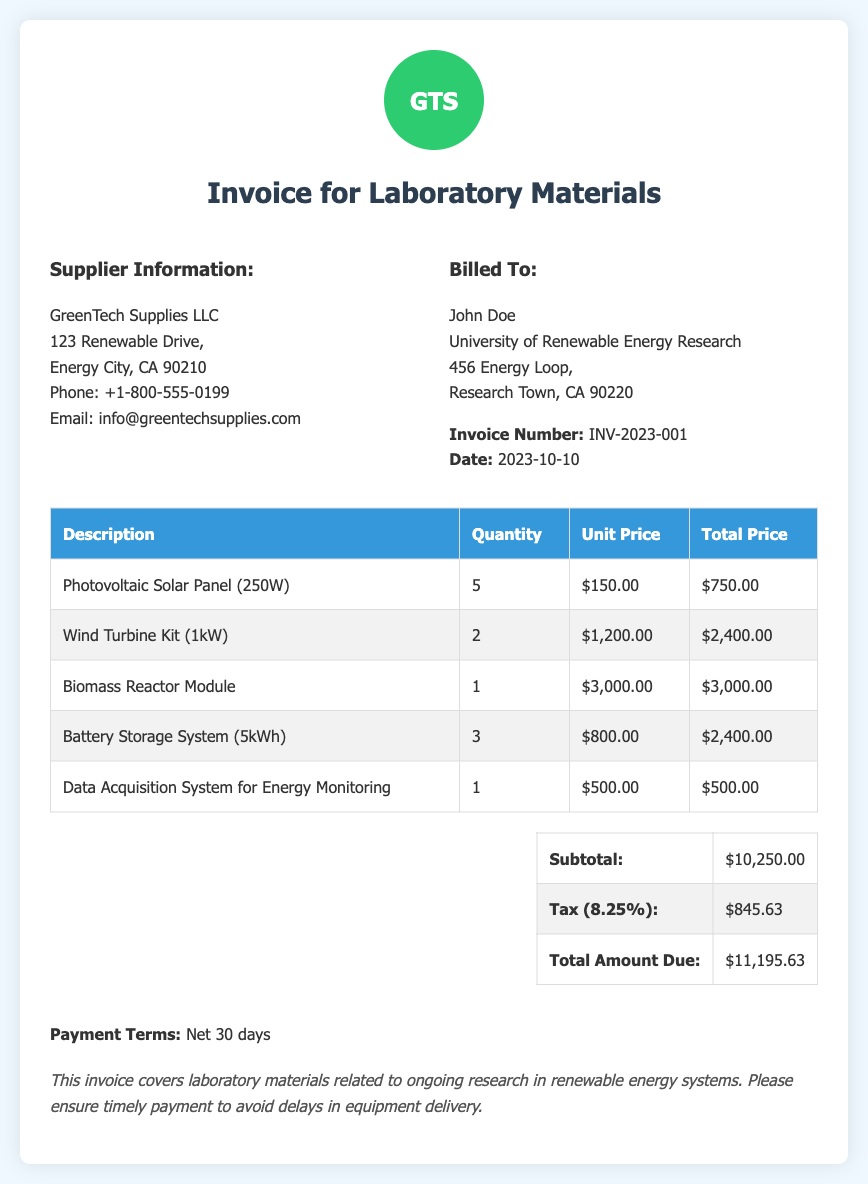What is the invoice number? The invoice number is specified near the billing details in the document.
Answer: INV-2023-001 What is the date of the invoice? The date of the invoice is mentioned along with the invoice number.
Answer: 2023-10-10 Who is the supplier? The supplier's name is listed in the supplier information section of the document.
Answer: GreenTech Supplies LLC What is the total amount due? The total amount due is calculated in the total section of the document.
Answer: $11,195.63 How many Photovoltaic Solar Panels were purchased? The quantity of Photovoltaic Solar Panels is found in the itemized list.
Answer: 5 What percentage is the tax applied? The tax percentage is specified in the total calculation section of the document.
Answer: 8.25% What item has the highest unit price? By comparing the itemized costs in the table, the item with the highest unit price can be identified.
Answer: Biomass Reactor Module What is the quantity of Wind Turbine Kits ordered? The quantity of Wind Turbine Kits is found in the itemized list of the invoice.
Answer: 2 What are the payment terms? The payment terms are stated towards the end of the document.
Answer: Net 30 days 